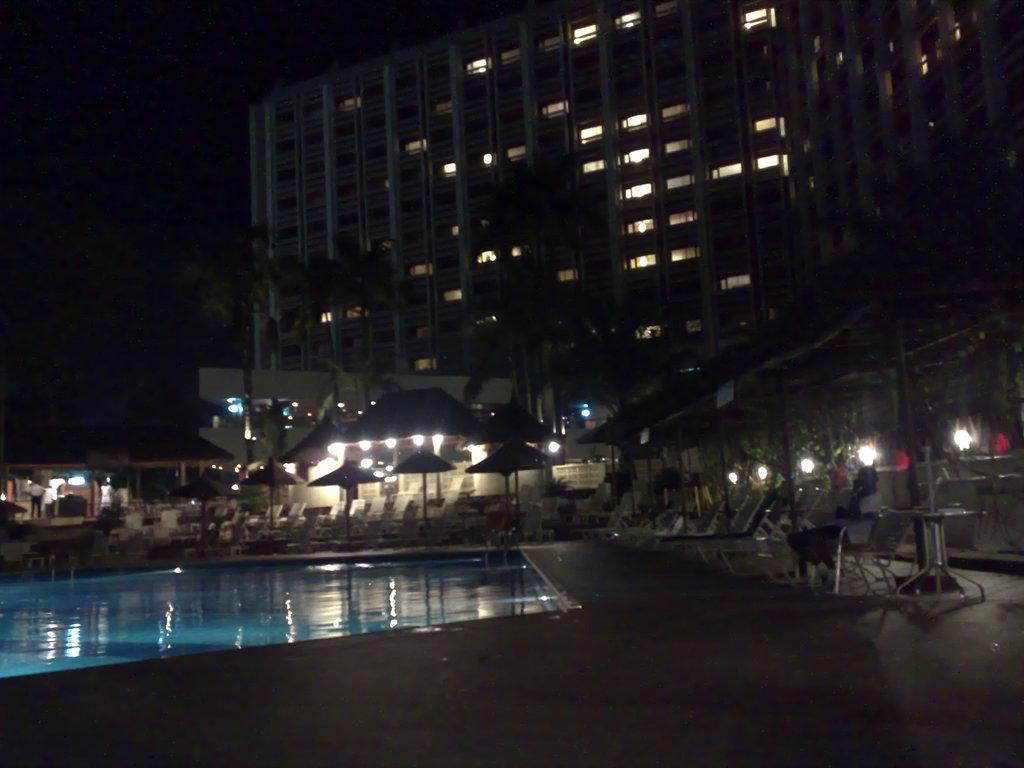What type of structures can be seen in the image? There are buildings in the image. What other natural elements are present in the image? There are trees in the image. What type of outdoor furniture is visible in the image? There are parasols, chaise lounges, and side tables in the image. Can you describe the person's position in the image? There is a person sitting on a chair in the image. What type of lighting is present in the image? There are electric lights in the image. What recreational feature is present in the image? There is a swimming pool in the image. What part of the natural environment is visible in the image? The sky is visible in the image. What type of silverware is being smashed by the pest in the image? There is no silverware or pest present in the image. What type of pest is causing damage to the silverware in the image? There is no pest or silverware present in the image. 